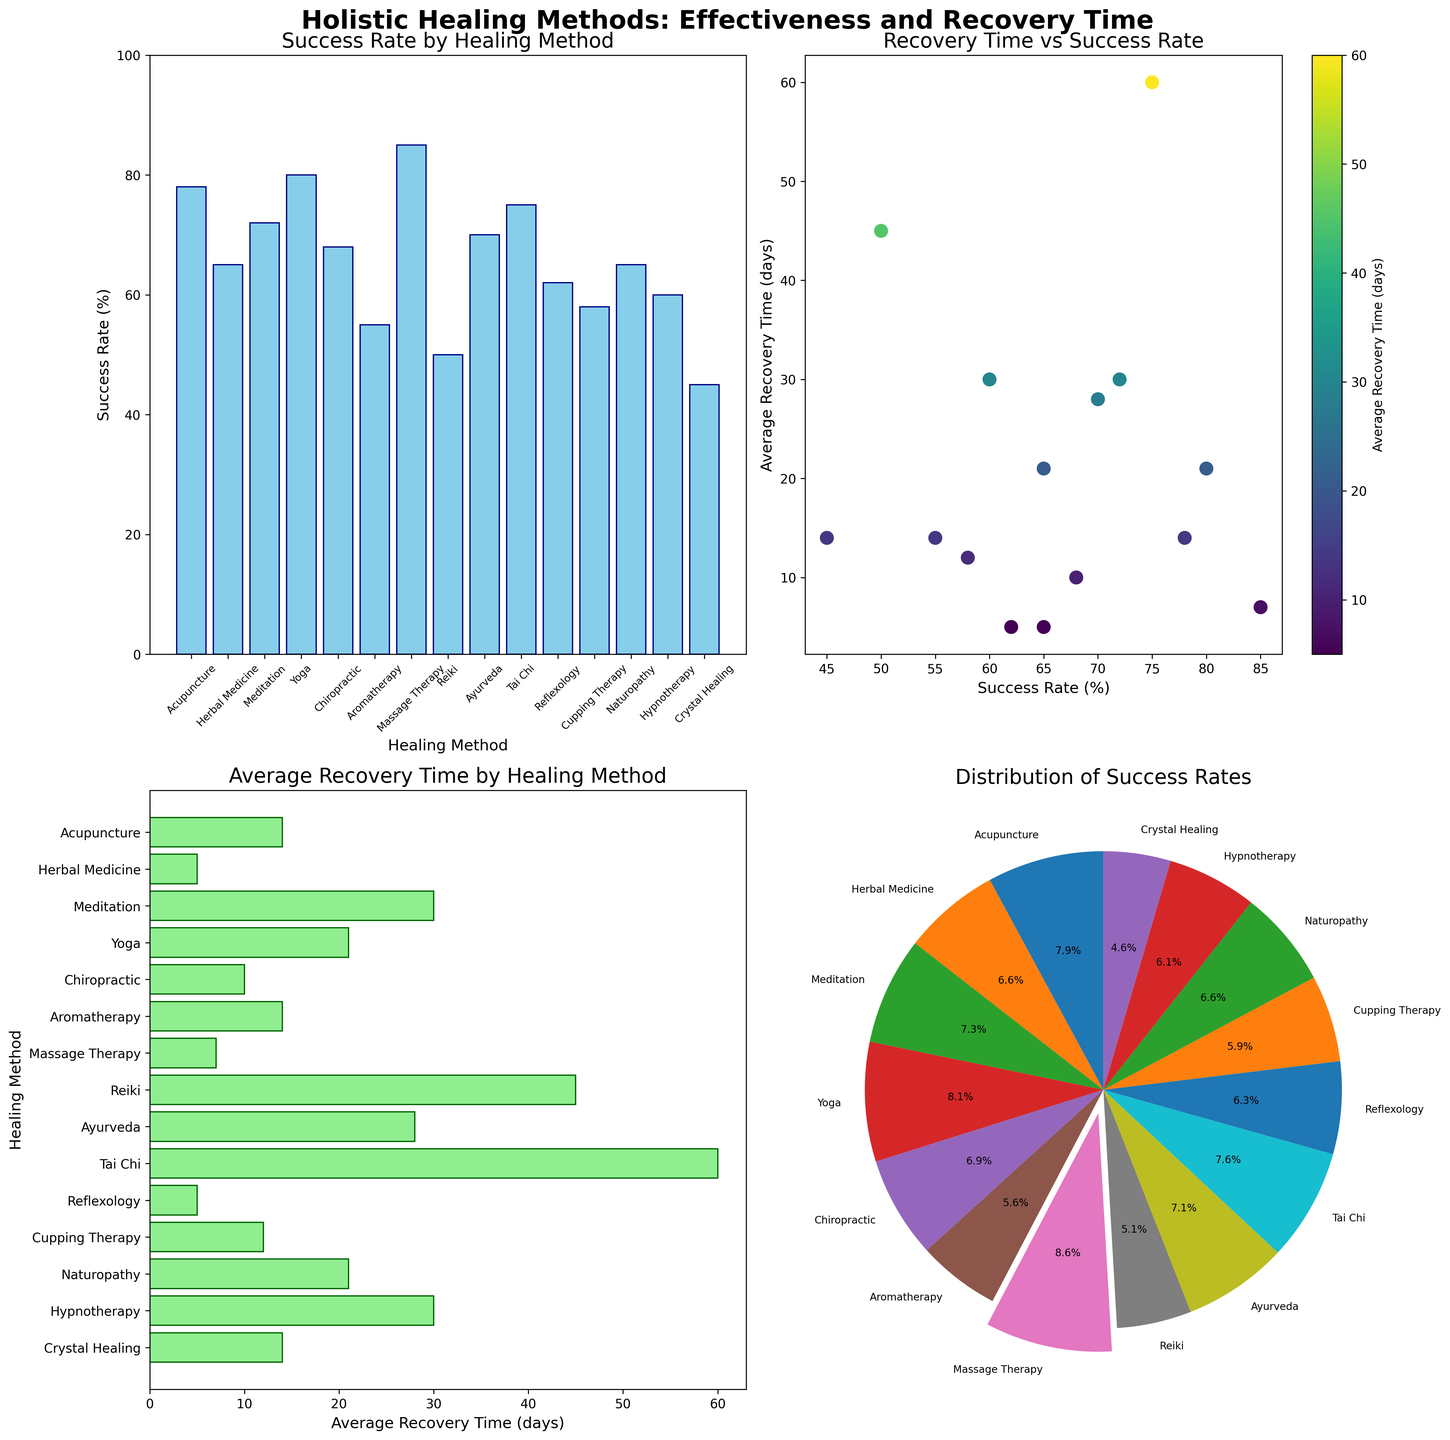What are the healing methods included in the 'Success Rate by Healing Method' bar plot? The 'Success Rate by Healing Method' bar plot lists all the healing methods that have bars associated with them. Reading from the x-axis, we see the methods are: Acupuncture, Herbal Medicine, Meditation, Yoga, Chiropractic, Aromatherapy, Massage Therapy, Reiki, Ayurveda, Tai Chi, Reflexology, Cupping Therapy, Naturopathy, Hypnotherapy, and Crystal Healing.
Answer: Acupuncture, Herbal Medicine, Meditation, Yoga, Chiropractic, Aromatherapy, Massage Therapy, Reiki, Ayurveda, Tai Chi, Reflexology, Cupping Therapy, Naturopathy, Hypnotherapy, Crystal Healing What is the highest success rate shown in the bar plot, and which healing method does it belong to? The highest bar in the 'Success Rate by Healing Method' plot represents the highest success rate. Observing the bar heights, the Massage Therapy bar is the tallest at 85%.
Answer: 85%, Massage Therapy What is the range of success rates shown in the scatter plot? The scatter plot shows points distributed along the x-axis, which represents success rates. The lowest success rate is 45% (Crystal Healing), and the highest is 85% (Massage Therapy). Therefore, the range of success rates is from 45% to 85%.
Answer: 45% to 85% Which healing method has the longest average recovery time, and what’s that time? In the 'Average Recovery Time by Healing Method' horizontal bar plot, the longest bar corresponds to the longest recovery time. Tai Chi shows the longest bar with an average recovery time of 60 days.
Answer: Tai Chi, 60 days How does the average recovery time for Meditation compare to that for Acupuncture? The 'Average Recovery Time by Healing Method' plot shows Meditation with a recovery time of 30 days, while Acupuncture has a recovery time of 14 days. Thus, the recovery time for Meditation is longer than for Acupuncture.
Answer: Meditation is longer Which healing method is highlighted in the pie chart, and why? The pie chart uses an exploding effect to highlight a specific segment. The segment with the highest success rate (Massage Therapy, 85%) is highlighted.
Answer: Massage Therapy, it has the highest success rate Does any healing method have a success rate lower than 50%? Observing the 'Success Rate by Healing Method' bar plot, we see that the bar for Crystal Healing is below the 50% mark at 45%. So, Crystal Healing has a success rate lower than 50%.
Answer: Yes, Crystal Healing What is the relationship between success rate and recovery time as seen in the scatter plot? The scatter plot shows points representing success rate versus average recovery time. Generally, there doesn’t seem to be a clear linear relationship, as both high and low success rates have various recovery times.
Answer: No clear relationship Which healing methods have a recovery time of 14 days as shown in the various plots? Both the bar plot for success rates and the horizontal bar plot for recovery times can be cross-referenced. Acupuncture and Aromatherapy show a recovery time of 14 days.
Answer: Acupuncture, Aromatherapy 